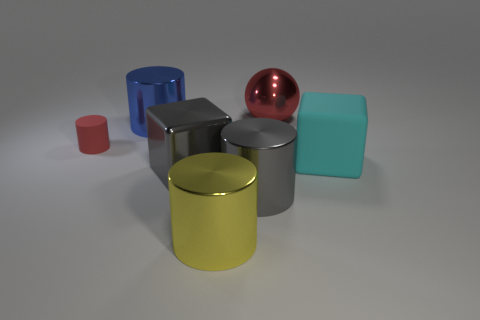What number of red objects have the same size as the gray cylinder?
Your answer should be very brief. 1. How many cyan things are metal blocks or large rubber things?
Give a very brief answer. 1. There is a red object that is behind the metallic cylinder behind the small object; what shape is it?
Offer a very short reply. Sphere. What shape is the red metallic thing that is the same size as the blue metal thing?
Make the answer very short. Sphere. Are there any shiny balls of the same color as the tiny cylinder?
Ensure brevity in your answer.  Yes. Are there the same number of large yellow metallic objects that are behind the red sphere and metallic balls right of the red cylinder?
Offer a very short reply. No. Do the large yellow metal thing and the red thing that is left of the blue metallic object have the same shape?
Offer a terse response. Yes. What number of other objects are there of the same material as the yellow cylinder?
Make the answer very short. 4. There is a gray metallic cylinder; are there any large cylinders in front of it?
Give a very brief answer. Yes. Do the yellow cylinder and the matte object that is on the left side of the gray cube have the same size?
Offer a very short reply. No. 